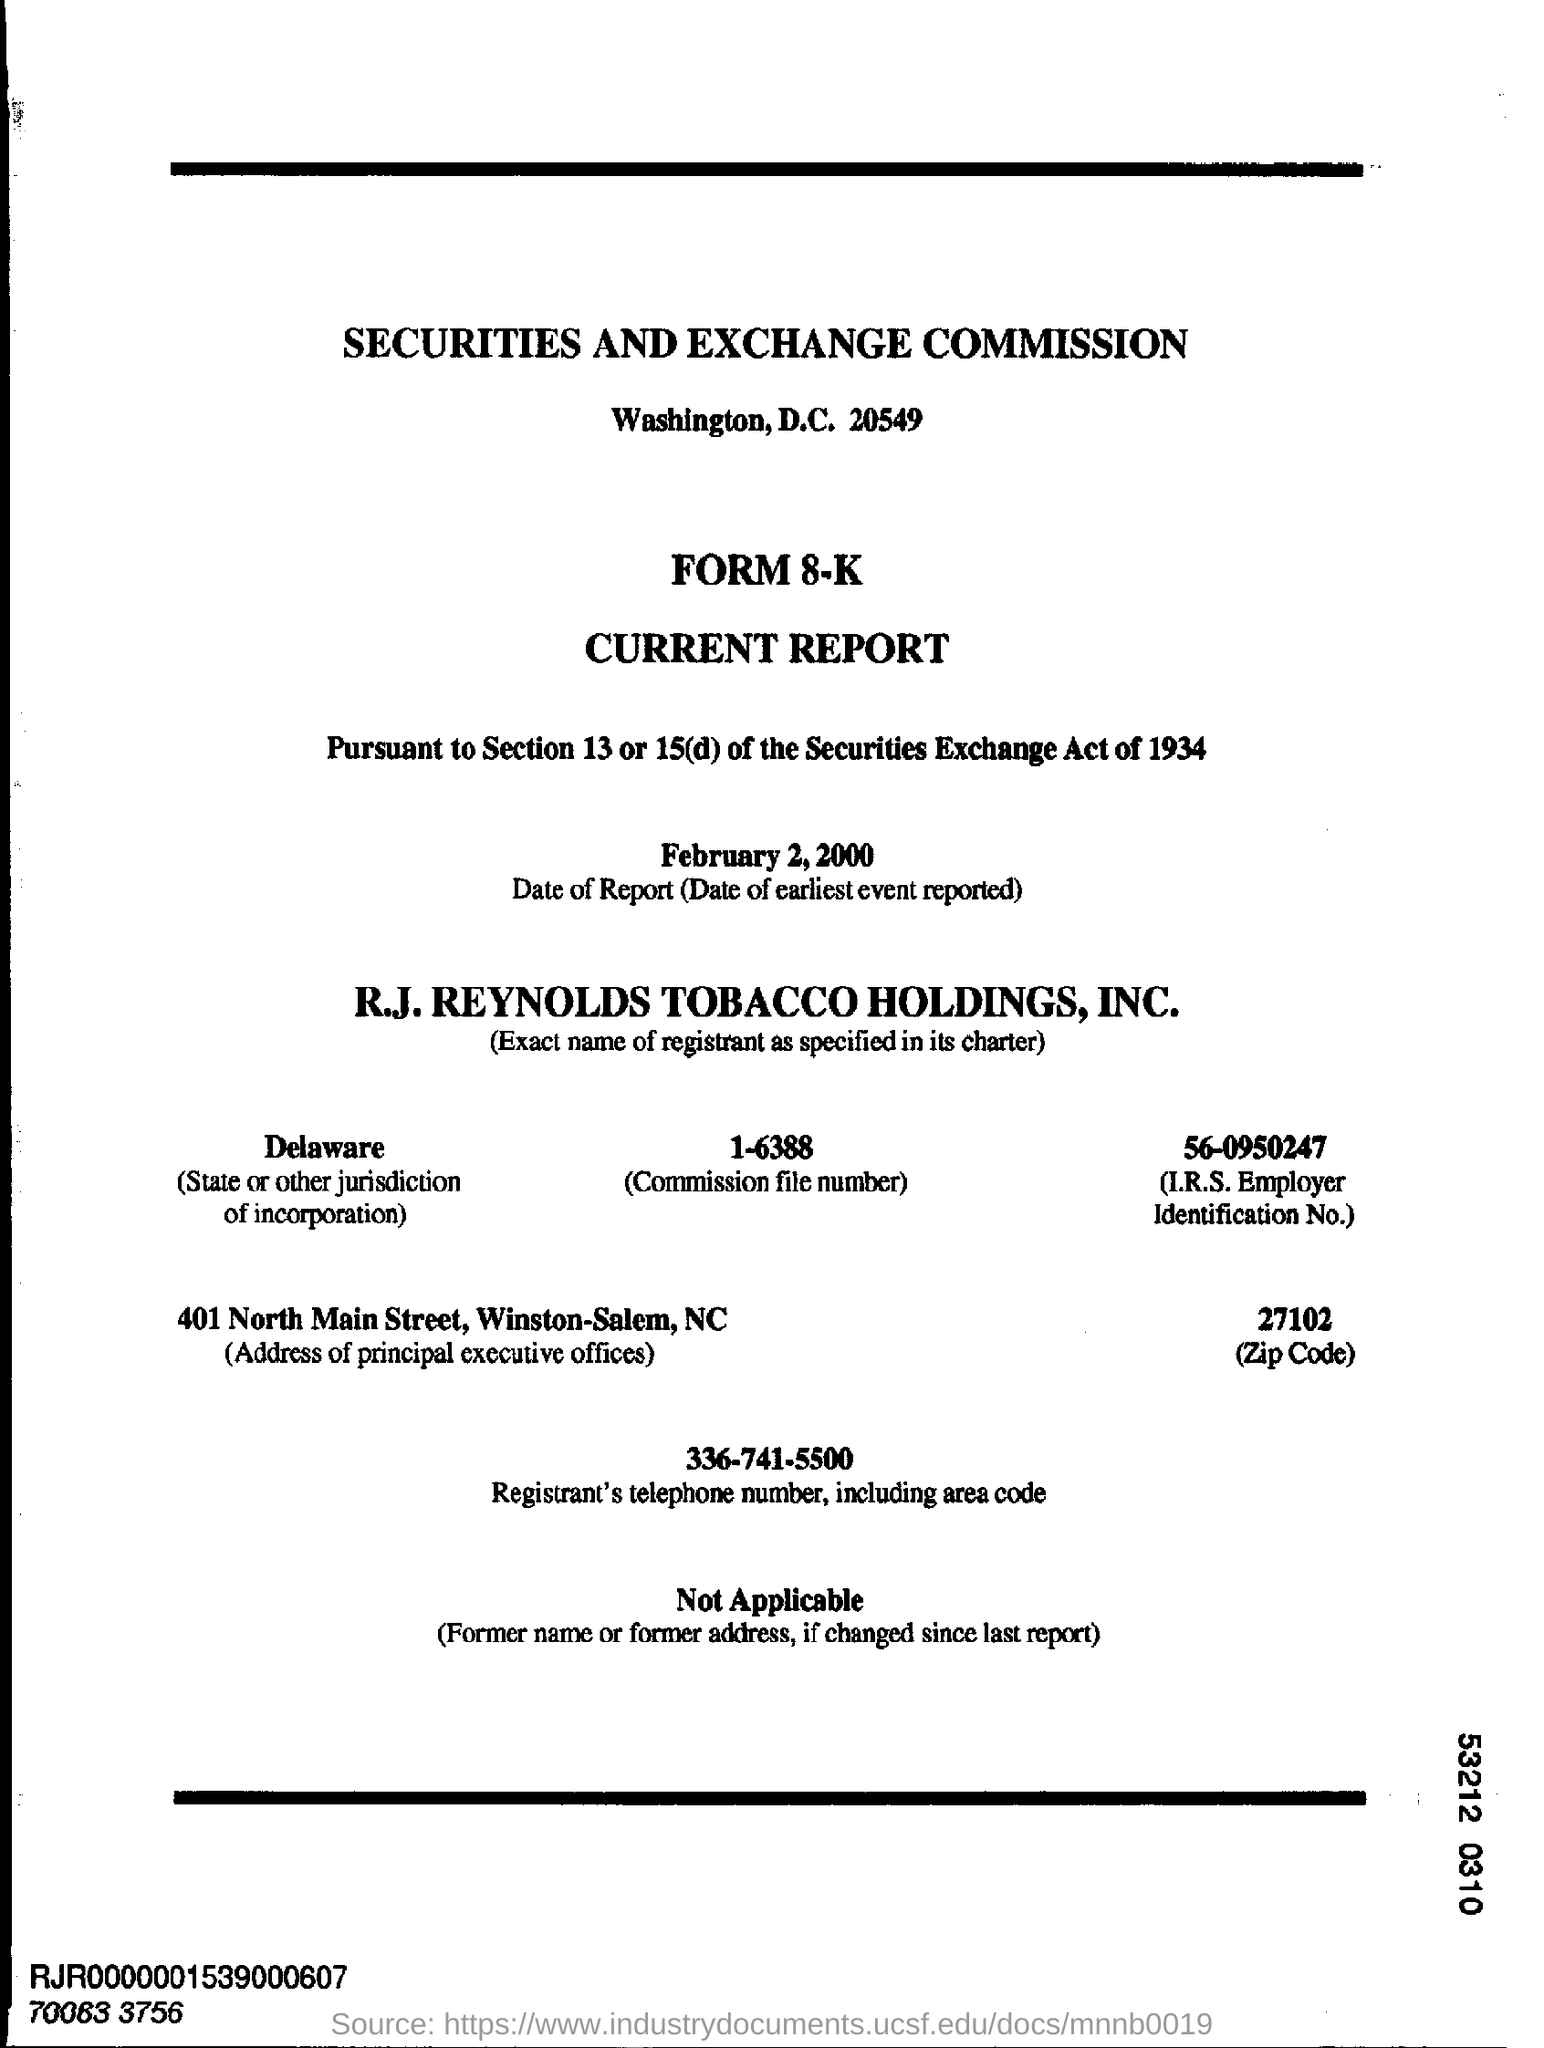Specify some key components in this picture. What is the Commission File Number?" it is a question that begins with "What is the Commission File No. 1-6388.. The date of report is February 2, 2000, which is the date of the earliest event reported. 